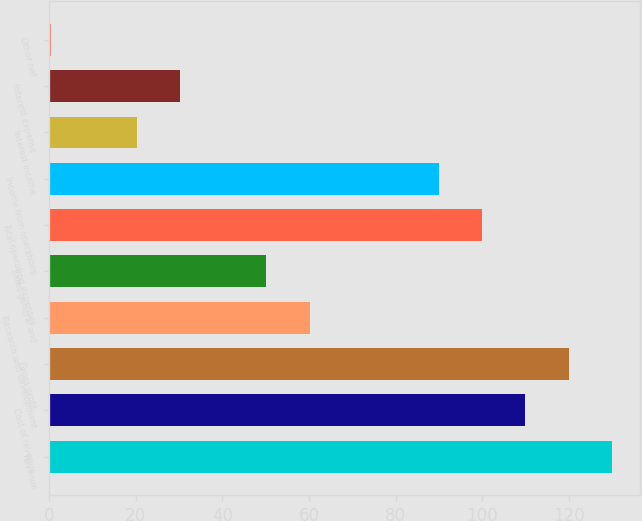Convert chart to OTSL. <chart><loc_0><loc_0><loc_500><loc_500><bar_chart><fcel>Revenue<fcel>Cost of revenue<fcel>Gross profit<fcel>Research and development<fcel>Sales general and<fcel>Total operating expenses<fcel>Income from operations<fcel>Interest income<fcel>Interest expense<fcel>Other net<nl><fcel>129.88<fcel>109.96<fcel>119.92<fcel>60.16<fcel>50.2<fcel>100<fcel>90.04<fcel>20.32<fcel>30.28<fcel>0.4<nl></chart> 